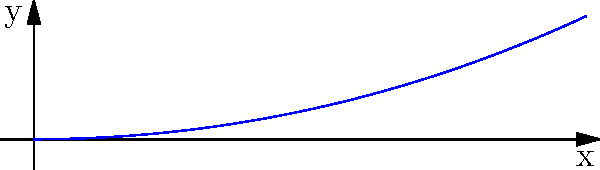As a beginner Python developer, you're tasked with plotting a simple spiral using polar coordinates. The spiral equation is given by $r = 0.1\theta$, where $r$ is the radius and $\theta$ is the angle in radians. Which Python library would be most suitable for creating this plot, and what key function would you use to generate the spiral coordinates? Let's break this down step-by-step:

1. First, we need to choose a suitable Python library for plotting. For beginners, matplotlib is often recommended due to its simplicity and extensive documentation.

2. To plot in polar coordinates using matplotlib, we can use the `polar()` function from the `pyplot` module.

3. We need to generate two arrays: one for $\theta$ (the angles) and one for $r$ (the radii).

4. For $\theta$, we can use `numpy.linspace()` to create an array of evenly spaced values from 0 to several times $2\pi$ (e.g., $4\pi$).

5. For $r$, we can use the given equation $r = 0.1\theta$. We can apply this equation directly to our $\theta$ array using NumPy's element-wise operations.

6. The key function to generate the spiral coordinates would be `numpy.linspace()` for $\theta$, and then a simple multiplication for $r$.

7. Finally, we would use `plt.polar(theta, r)` to create the spiral plot.

Here's a commented code snippet that implements this:

```python
import numpy as np
import matplotlib.pyplot as plt

# Generate theta values from 0 to 4pi
theta = np.linspace(0, 4*np.pi, 1000)

# Calculate r using the equation r = 0.1*theta
r = 0.1 * theta

# Create the polar plot
plt.polar(theta, r)
plt.title('Simple Spiral')
plt.show()
```

This approach uses NumPy's `linspace()` function as the key to generating the spiral coordinates, which is both efficient and easy to understand for beginners.
Answer: matplotlib with numpy.linspace() 